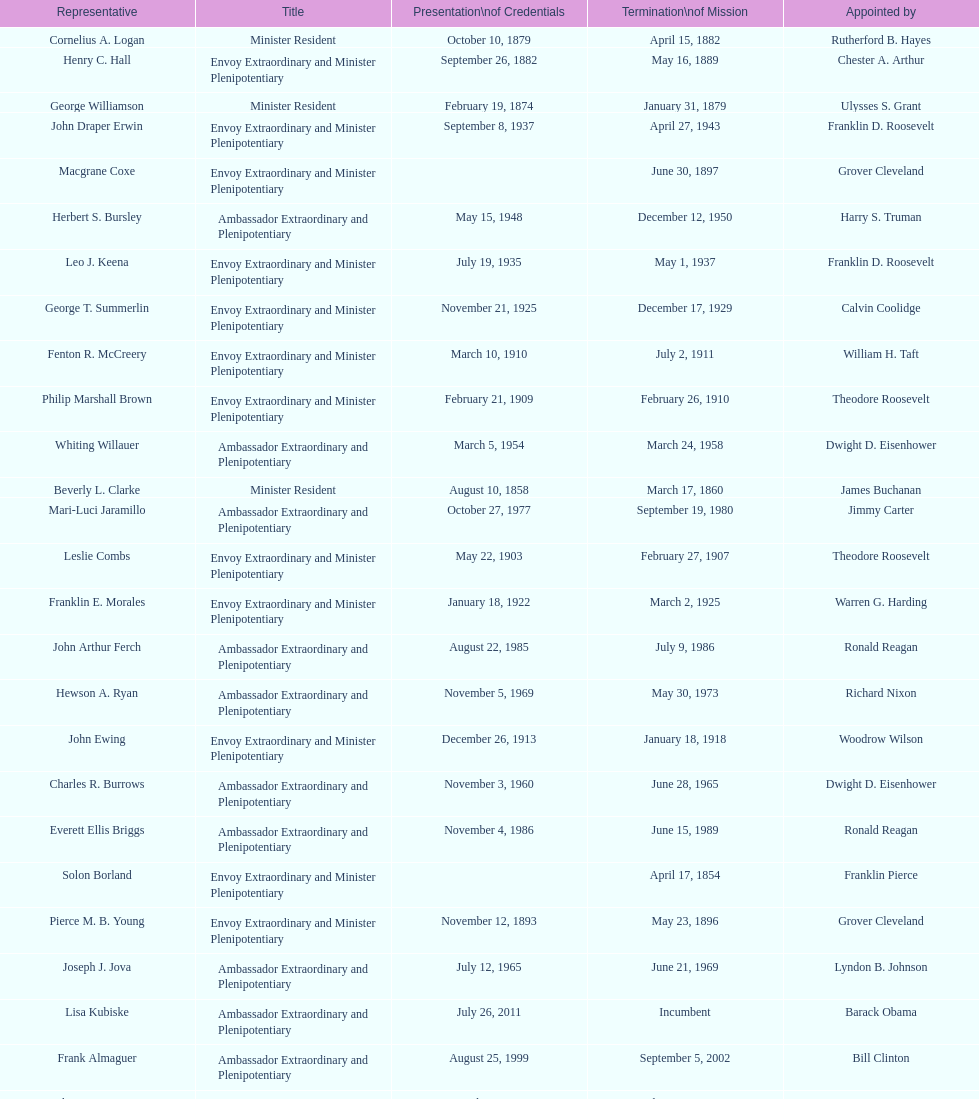Who became the ambassador after the completion of hewson ryan's mission? Phillip V. Sanchez. 